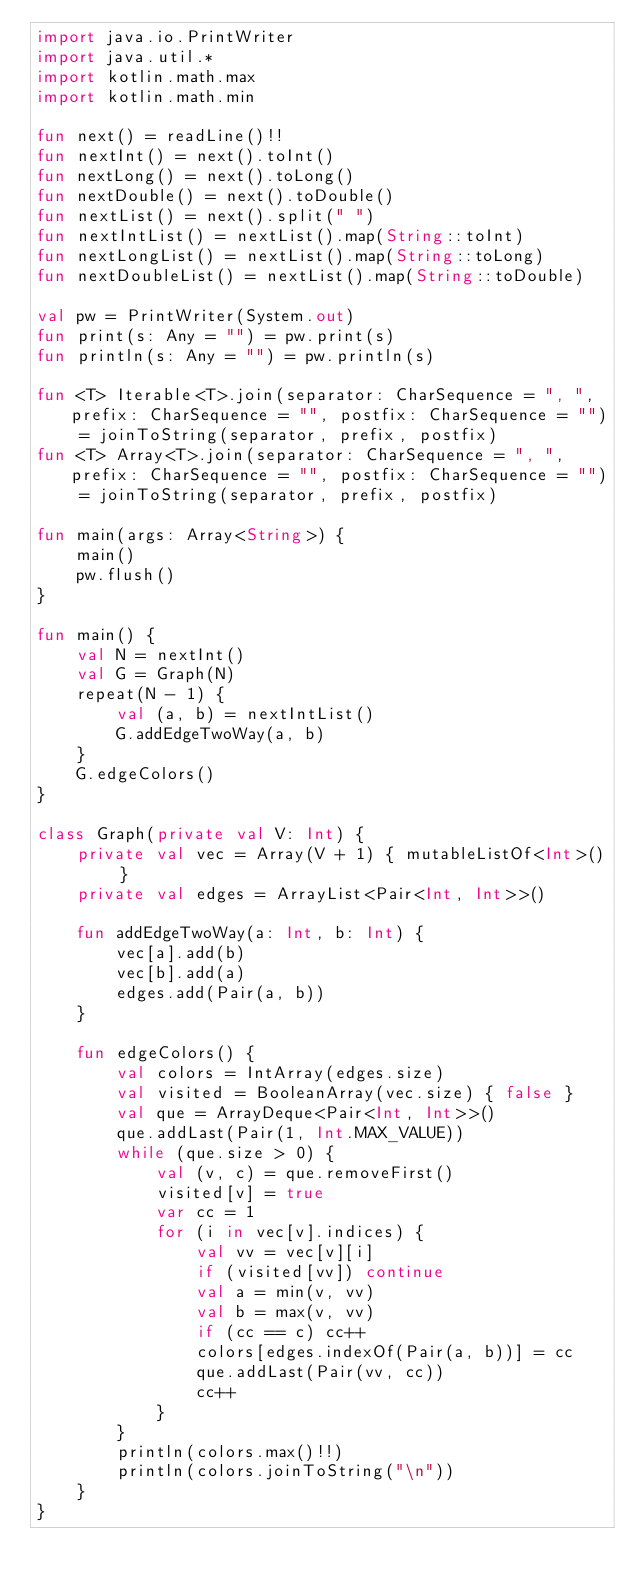<code> <loc_0><loc_0><loc_500><loc_500><_Kotlin_>import java.io.PrintWriter
import java.util.*
import kotlin.math.max
import kotlin.math.min

fun next() = readLine()!!
fun nextInt() = next().toInt()
fun nextLong() = next().toLong()
fun nextDouble() = next().toDouble()
fun nextList() = next().split(" ")
fun nextIntList() = nextList().map(String::toInt)
fun nextLongList() = nextList().map(String::toLong)
fun nextDoubleList() = nextList().map(String::toDouble)

val pw = PrintWriter(System.out)
fun print(s: Any = "") = pw.print(s)
fun println(s: Any = "") = pw.println(s)

fun <T> Iterable<T>.join(separator: CharSequence = ", ", prefix: CharSequence = "", postfix: CharSequence = "") = joinToString(separator, prefix, postfix)
fun <T> Array<T>.join(separator: CharSequence = ", ", prefix: CharSequence = "", postfix: CharSequence = "") = joinToString(separator, prefix, postfix)

fun main(args: Array<String>) {
    main()
    pw.flush()
}

fun main() {
    val N = nextInt()
    val G = Graph(N)
    repeat(N - 1) {
        val (a, b) = nextIntList()
        G.addEdgeTwoWay(a, b)
    }
    G.edgeColors()
}

class Graph(private val V: Int) {
    private val vec = Array(V + 1) { mutableListOf<Int>() }
    private val edges = ArrayList<Pair<Int, Int>>()

    fun addEdgeTwoWay(a: Int, b: Int) {
        vec[a].add(b)
        vec[b].add(a)
        edges.add(Pair(a, b))
    }

    fun edgeColors() {
        val colors = IntArray(edges.size)
        val visited = BooleanArray(vec.size) { false }
        val que = ArrayDeque<Pair<Int, Int>>()
        que.addLast(Pair(1, Int.MAX_VALUE))
        while (que.size > 0) {
            val (v, c) = que.removeFirst()
            visited[v] = true
            var cc = 1
            for (i in vec[v].indices) {
                val vv = vec[v][i]
                if (visited[vv]) continue
                val a = min(v, vv)
                val b = max(v, vv)
                if (cc == c) cc++
                colors[edges.indexOf(Pair(a, b))] = cc
                que.addLast(Pair(vv, cc))
                cc++
            }
        }
        println(colors.max()!!)
        println(colors.joinToString("\n"))
    }
}</code> 